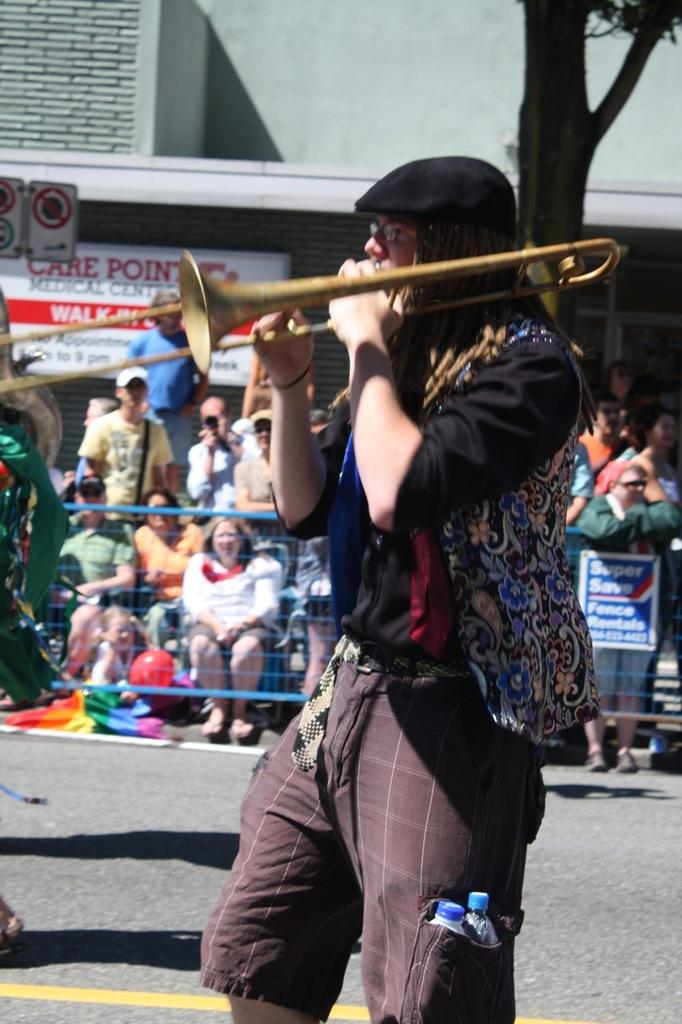What is the person in the image doing? There is a person playing a musical instrument in the image. What else can be seen in the image besides the person playing the instrument? There is a traffic sign board in the image. What is the setting of the image? A group of people are sitting aside of a road in the image. What type of structure is visible in the image? There is a building visible in the image. How many chairs are present in the image? There is no mention of chairs in the image, so we cannot determine the number of chairs present. 